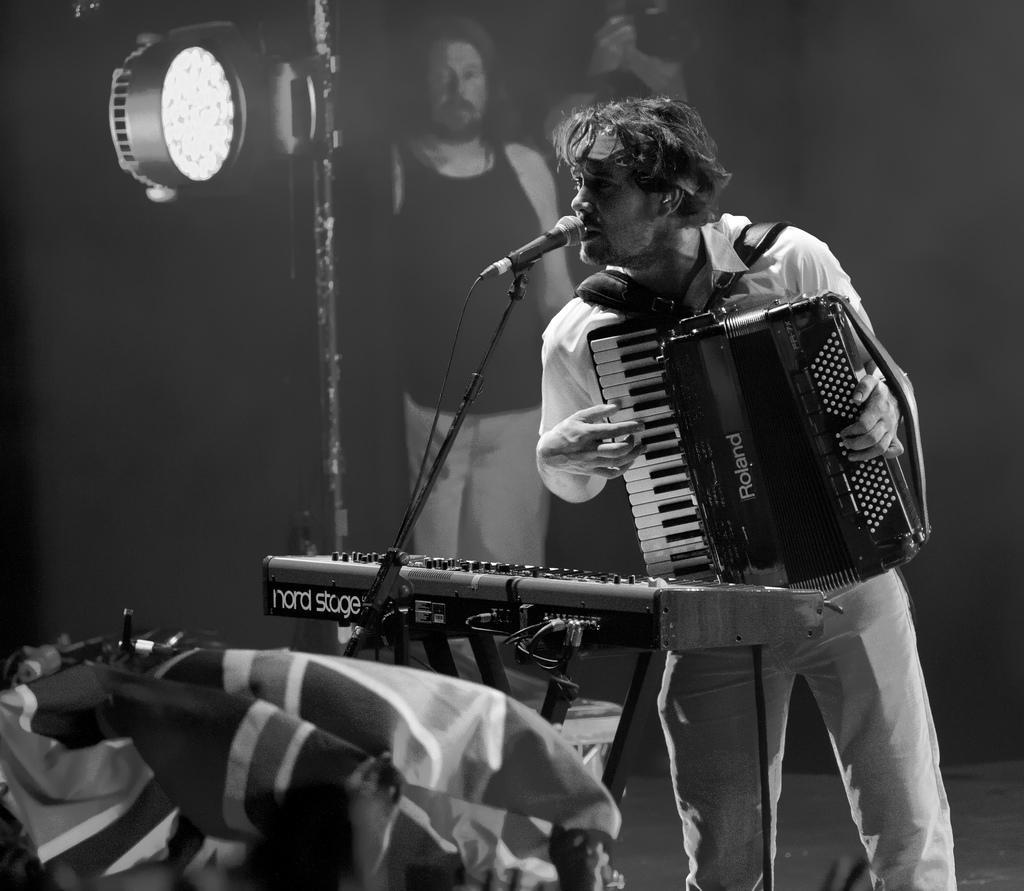Please provide a concise description of this image. In this image I can see a person holding a piano and in front of them I can see mike and a pole and a light attached to the pole and at the bottom I can see clothes and at the top I can see another person 